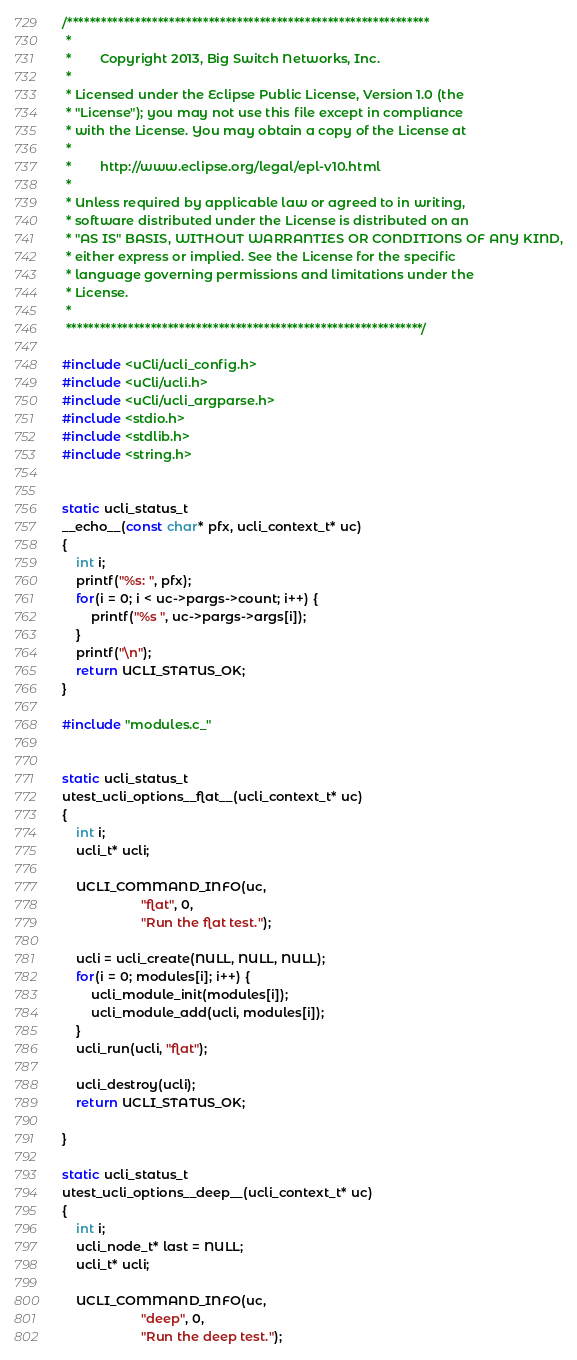Convert code to text. <code><loc_0><loc_0><loc_500><loc_500><_C_>/****************************************************************
 *
 *        Copyright 2013, Big Switch Networks, Inc.
 *
 * Licensed under the Eclipse Public License, Version 1.0 (the
 * "License"); you may not use this file except in compliance
 * with the License. You may obtain a copy of the License at
 *
 *        http://www.eclipse.org/legal/epl-v10.html
 *
 * Unless required by applicable law or agreed to in writing,
 * software distributed under the License is distributed on an
 * "AS IS" BASIS, WITHOUT WARRANTIES OR CONDITIONS OF ANY KIND,
 * either express or implied. See the License for the specific
 * language governing permissions and limitations under the
 * License.
 *
 ***************************************************************/

#include <uCli/ucli_config.h>
#include <uCli/ucli.h>
#include <uCli/ucli_argparse.h>
#include <stdio.h>
#include <stdlib.h>
#include <string.h>


static ucli_status_t
__echo__(const char* pfx, ucli_context_t* uc)
{
    int i;
    printf("%s: ", pfx);
    for(i = 0; i < uc->pargs->count; i++) {
        printf("%s ", uc->pargs->args[i]);
    }
    printf("\n");
    return UCLI_STATUS_OK;
}

#include "modules.c_"


static ucli_status_t
utest_ucli_options__flat__(ucli_context_t* uc)
{
    int i;
    ucli_t* ucli;

    UCLI_COMMAND_INFO(uc,
                      "flat", 0,
                      "Run the flat test.");

    ucli = ucli_create(NULL, NULL, NULL);
    for(i = 0; modules[i]; i++) {
        ucli_module_init(modules[i]);
        ucli_module_add(ucli, modules[i]);
    }
    ucli_run(ucli, "flat");

    ucli_destroy(ucli);
    return UCLI_STATUS_OK;

}

static ucli_status_t
utest_ucli_options__deep__(ucli_context_t* uc)
{
    int i;
    ucli_node_t* last = NULL;
    ucli_t* ucli;

    UCLI_COMMAND_INFO(uc,
                      "deep", 0,
                      "Run the deep test.");
</code> 